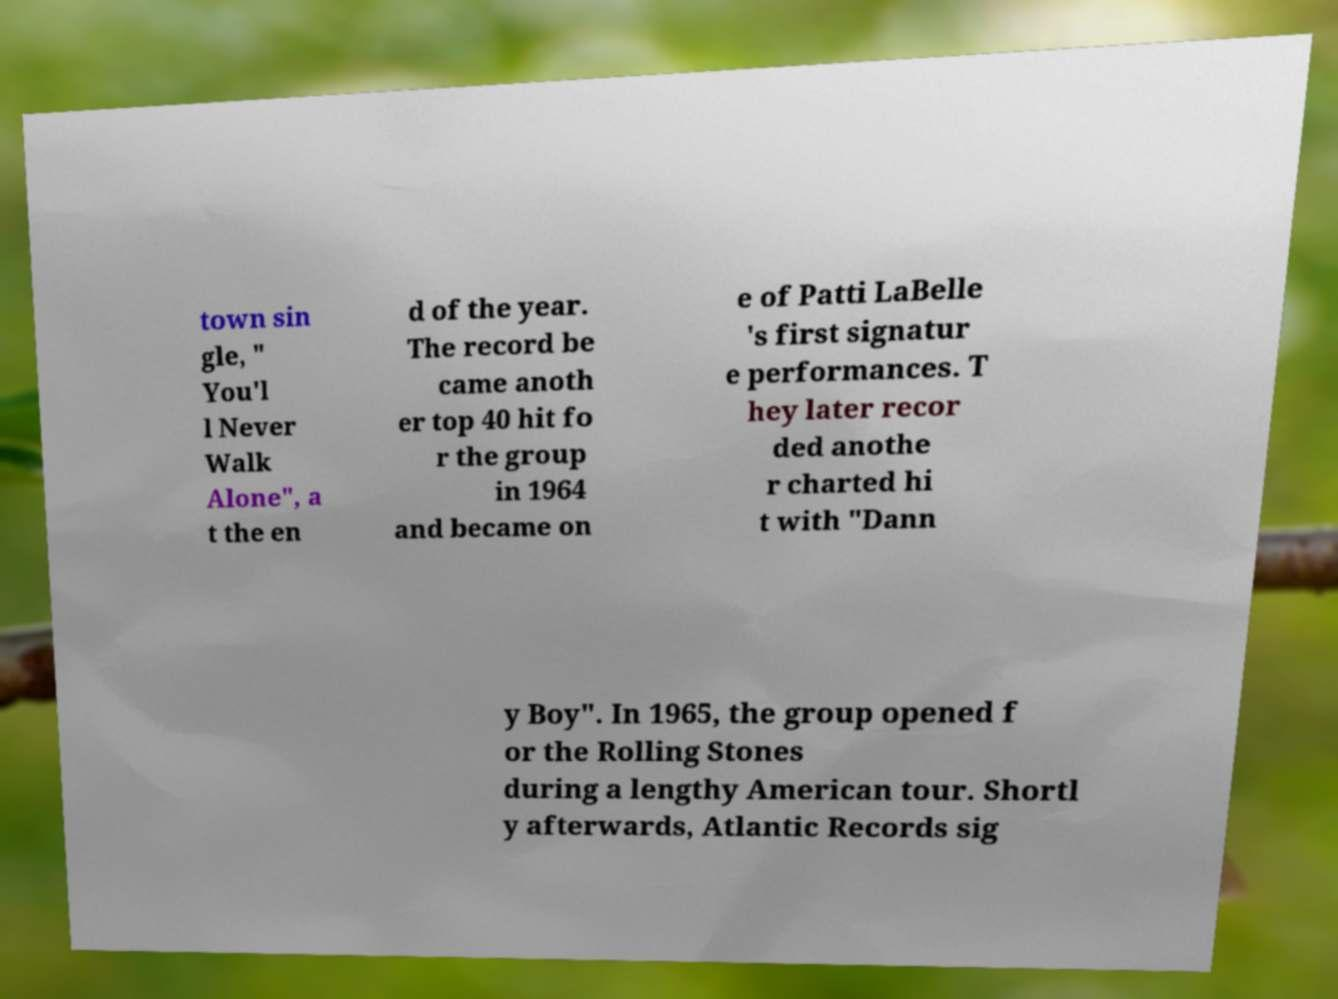Please read and relay the text visible in this image. What does it say? town sin gle, " You'l l Never Walk Alone", a t the en d of the year. The record be came anoth er top 40 hit fo r the group in 1964 and became on e of Patti LaBelle 's first signatur e performances. T hey later recor ded anothe r charted hi t with "Dann y Boy". In 1965, the group opened f or the Rolling Stones during a lengthy American tour. Shortl y afterwards, Atlantic Records sig 